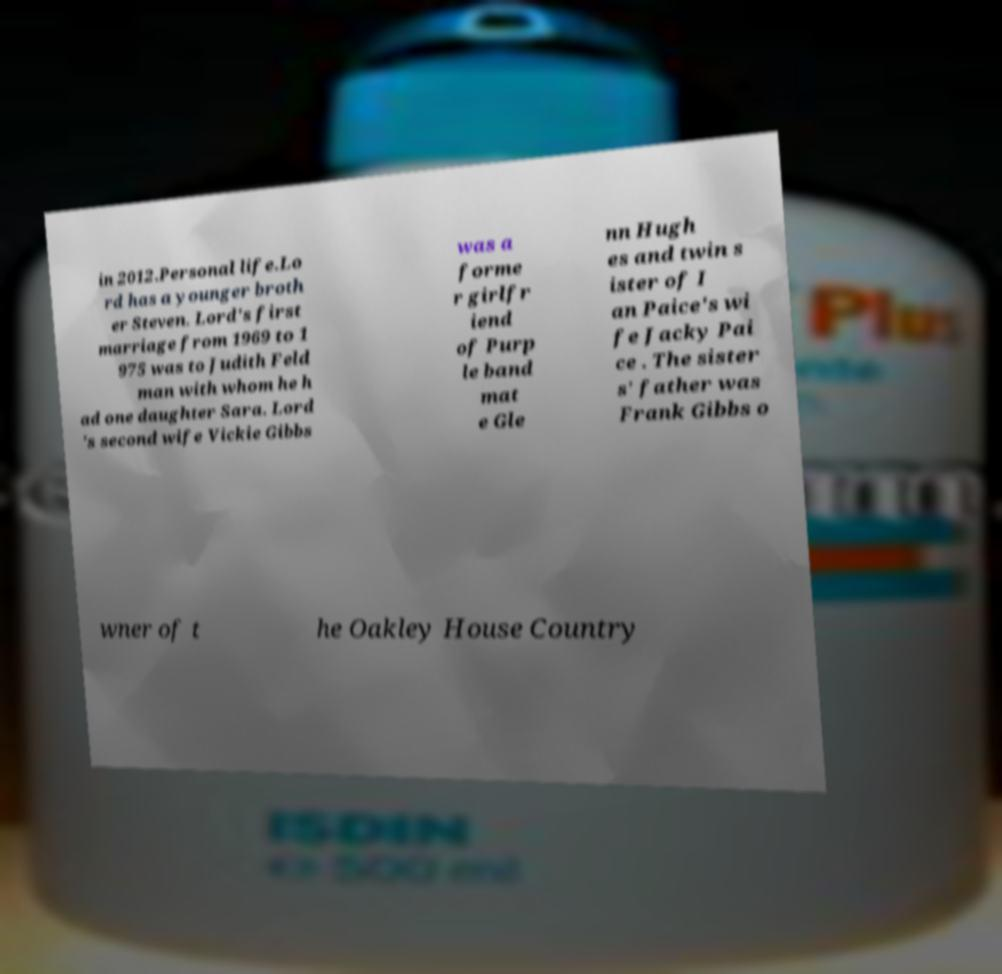Could you assist in decoding the text presented in this image and type it out clearly? in 2012.Personal life.Lo rd has a younger broth er Steven. Lord's first marriage from 1969 to 1 975 was to Judith Feld man with whom he h ad one daughter Sara. Lord 's second wife Vickie Gibbs was a forme r girlfr iend of Purp le band mat e Gle nn Hugh es and twin s ister of I an Paice's wi fe Jacky Pai ce . The sister s' father was Frank Gibbs o wner of t he Oakley House Country 